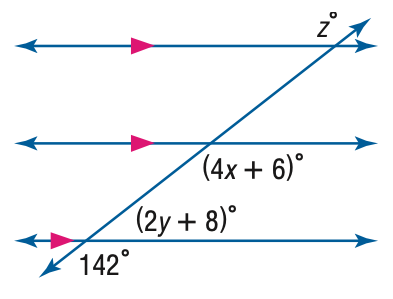Answer the mathemtical geometry problem and directly provide the correct option letter.
Question: Find y in the figure.
Choices: A: 15 B: 34 C: 67 D: 75 A 